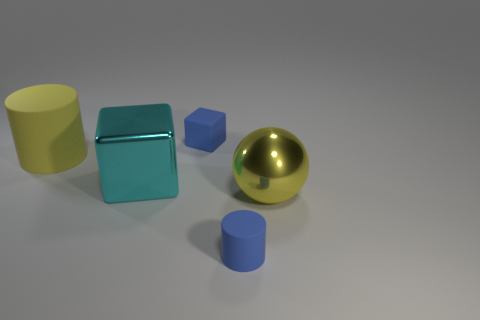Add 2 big balls. How many objects exist? 7 Subtract all cylinders. How many objects are left? 3 Subtract 1 blue cylinders. How many objects are left? 4 Subtract all cyan metallic blocks. Subtract all blue rubber things. How many objects are left? 2 Add 4 big cylinders. How many big cylinders are left? 5 Add 3 cyan blocks. How many cyan blocks exist? 4 